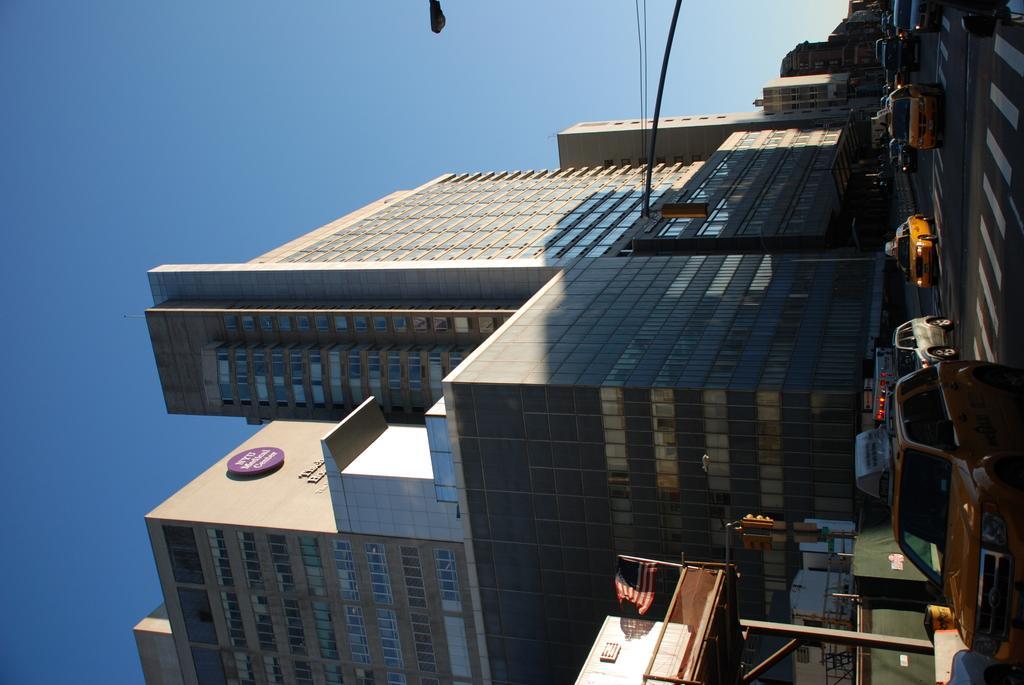Can you describe this image briefly? In this image we can see the buildings, flag, traffic signal light pole and also light pole with wires. On the right we can see the vehicles passing on the road. In the background we can see the sky. 